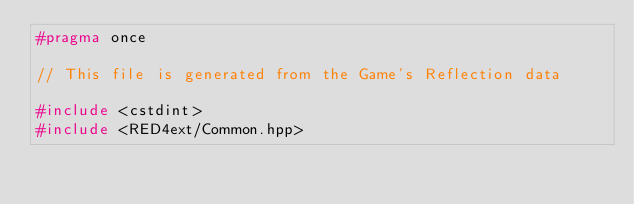Convert code to text. <code><loc_0><loc_0><loc_500><loc_500><_C++_>#pragma once

// This file is generated from the Game's Reflection data

#include <cstdint>
#include <RED4ext/Common.hpp></code> 